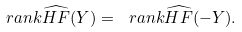<formula> <loc_0><loc_0><loc_500><loc_500>\ r a n k \widehat { H F } ( Y ) = \ r a n k \widehat { H F } ( - Y ) .</formula> 